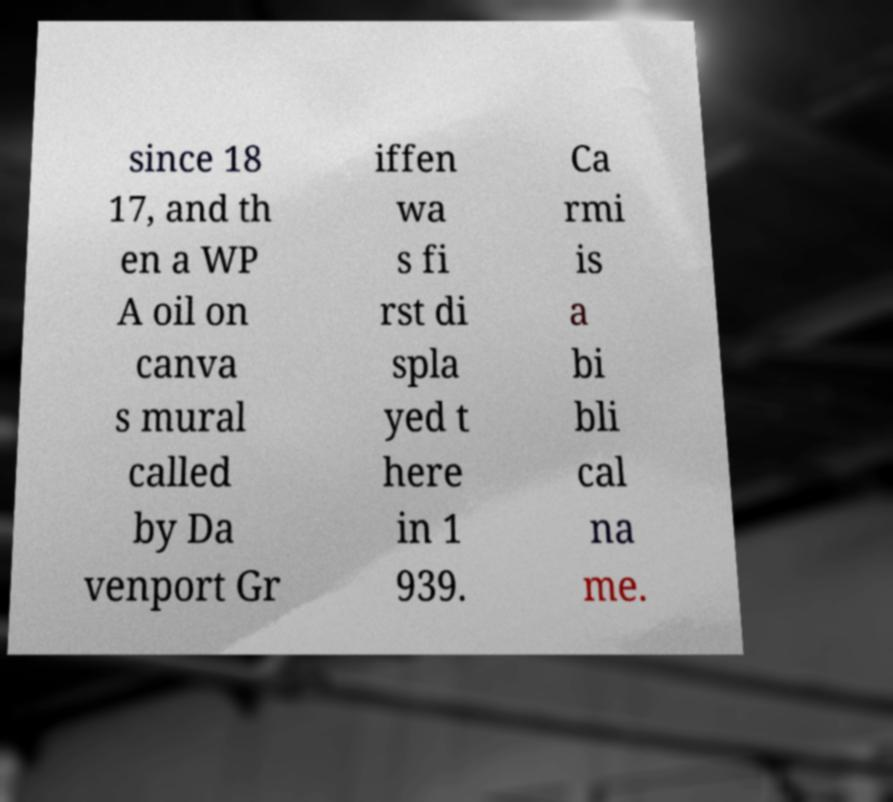Can you read and provide the text displayed in the image?This photo seems to have some interesting text. Can you extract and type it out for me? since 18 17, and th en a WP A oil on canva s mural called by Da venport Gr iffen wa s fi rst di spla yed t here in 1 939. Ca rmi is a bi bli cal na me. 